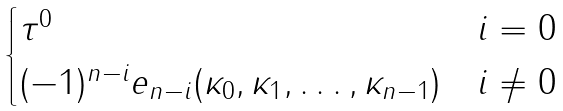<formula> <loc_0><loc_0><loc_500><loc_500>\begin{cases} \tau ^ { 0 } & i = 0 \\ ( - 1 ) ^ { n - i } e _ { n - i } ( \kappa _ { 0 } , \kappa _ { 1 } , \dots , \kappa _ { n - 1 } ) & i \ne 0 \end{cases}</formula> 